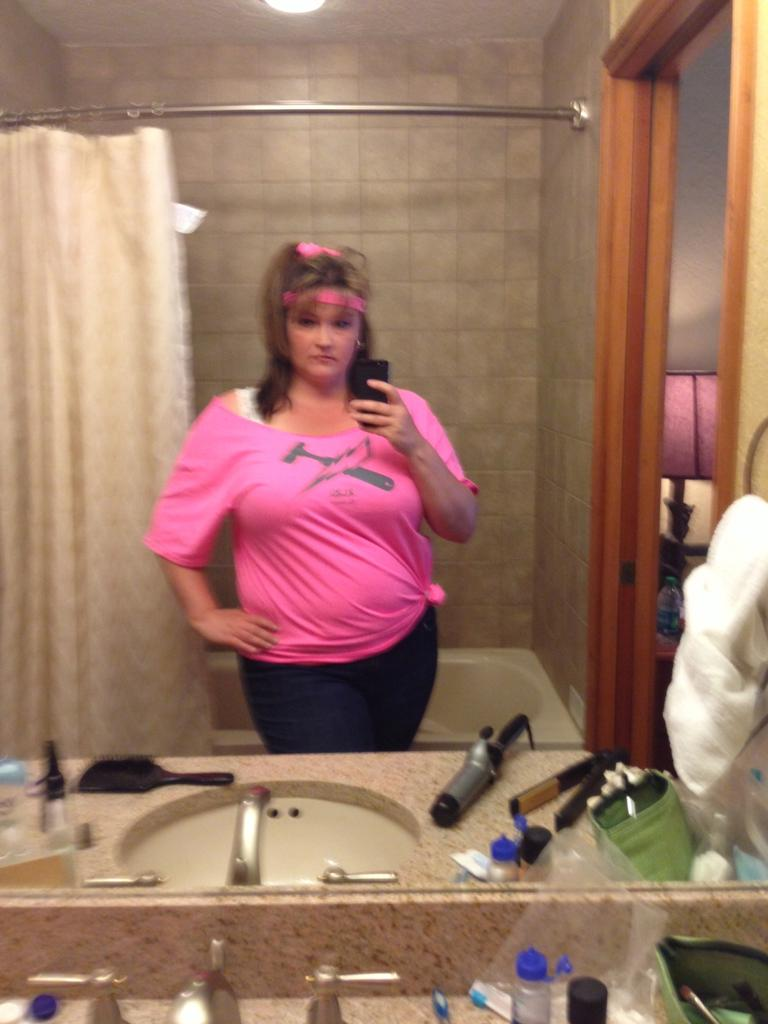Who is present in the image? There is a woman in the image. Where is the woman located? The woman is standing in a washroom. What is the woman doing in the image? The woman is taking a selfie in the mirror. What is the woman wearing in the image? The woman is wearing a pink t-shirt. What object is present in the image that allows the woman to see herself? There is a mirror in the image. What can be seen outside the washroom in the image? The sea is visible in the image. What order does the woman give to the existence in the image? There is no order given by the woman in the image, and the concept of "existence" is not applicable to the context of the image. 